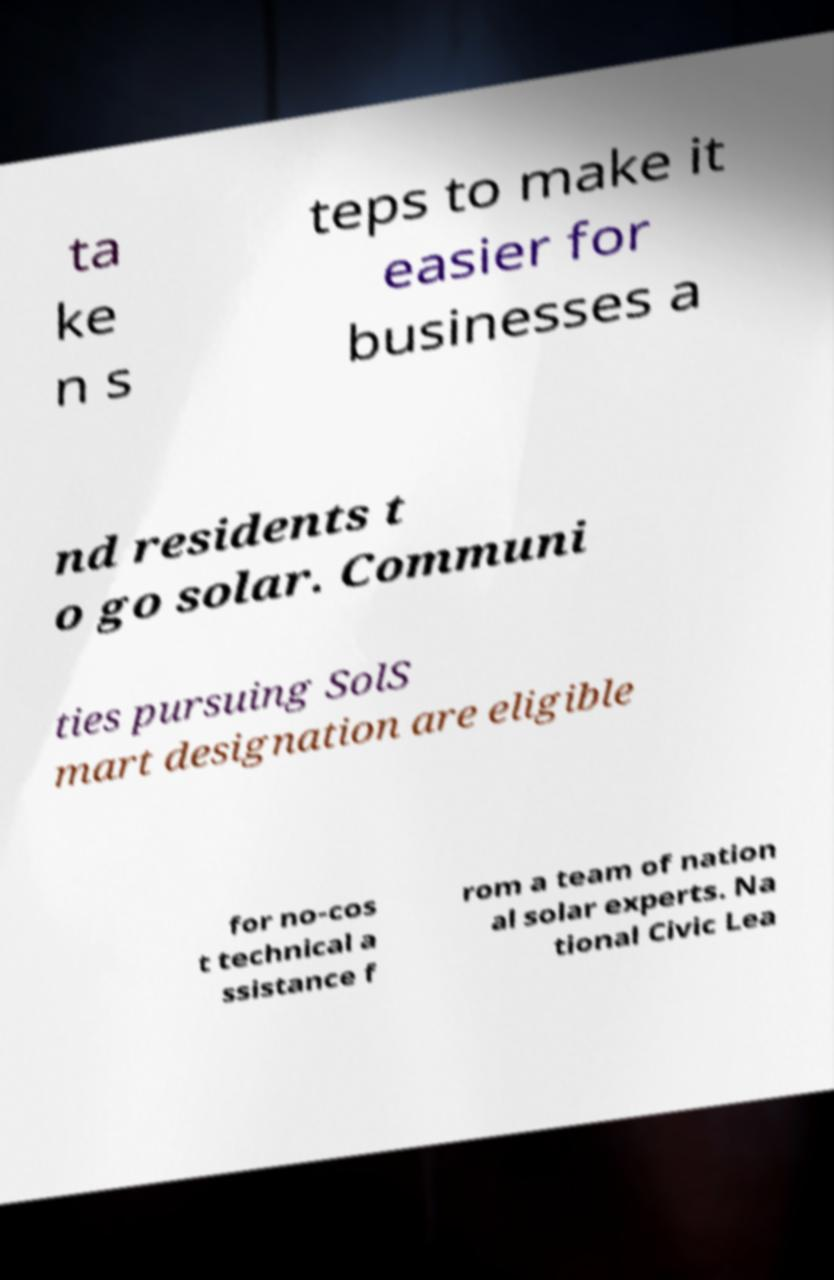Could you extract and type out the text from this image? ta ke n s teps to make it easier for businesses a nd residents t o go solar. Communi ties pursuing SolS mart designation are eligible for no-cos t technical a ssistance f rom a team of nation al solar experts. Na tional Civic Lea 